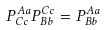Convert formula to latex. <formula><loc_0><loc_0><loc_500><loc_500>P _ { C c } ^ { A a } P _ { B b } ^ { C c } = P _ { B b } ^ { A a }</formula> 